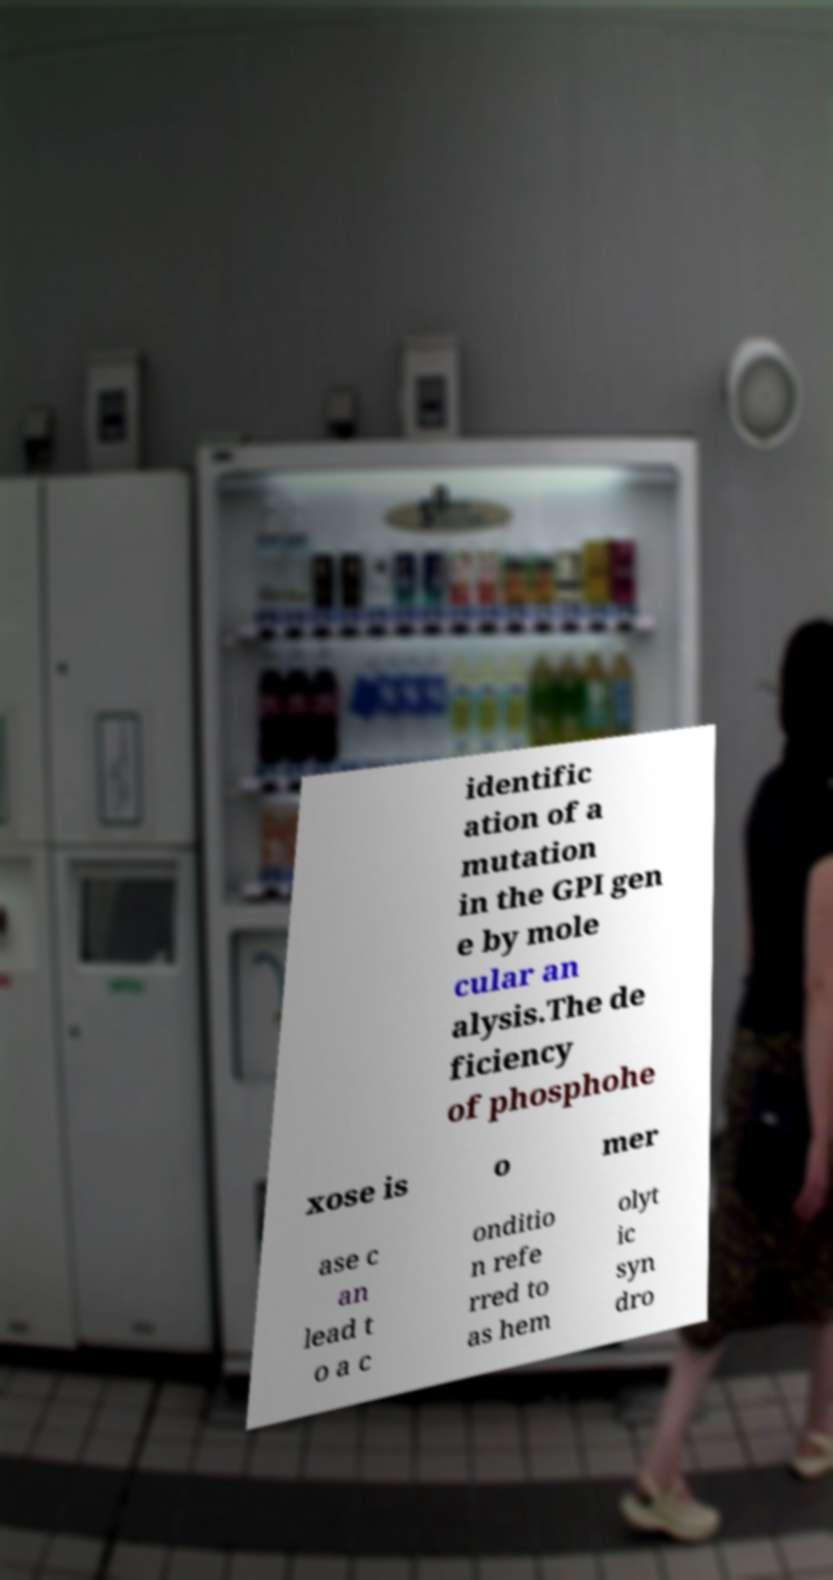I need the written content from this picture converted into text. Can you do that? identific ation of a mutation in the GPI gen e by mole cular an alysis.The de ficiency of phosphohe xose is o mer ase c an lead t o a c onditio n refe rred to as hem olyt ic syn dro 